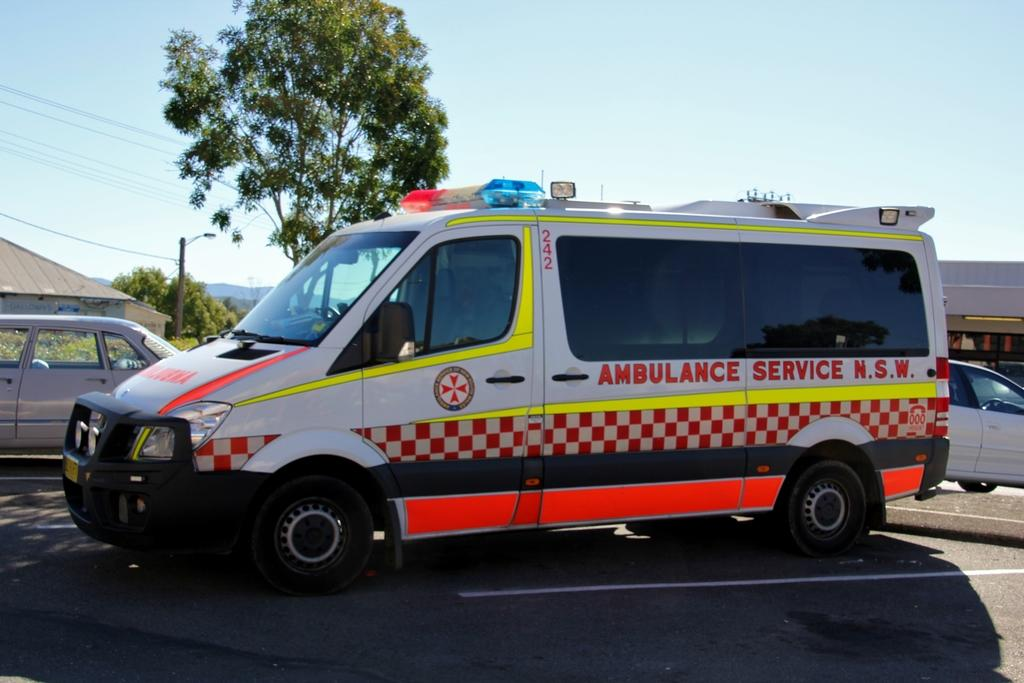What type of vehicle is present in the image? There is an ambulance in the image. What else can be seen on the road in the image? There are vehicles on the road in the image. What type of structures are visible in the image? There are houses in the image. What type of natural elements can be seen in the image? There are trees and hills in the image. What is the purpose of the pole in the image? The pole is likely used for supporting cables, as there are cables visible in the image. What is attached to the pole in the image? There is a light attached to the pole in the image. What is visible in the background of the image? The sky is visible in the background of the image. What type of hobbies do the people in the oven enjoy in the image? There is no oven or people engaged in hobbies present in the image. 